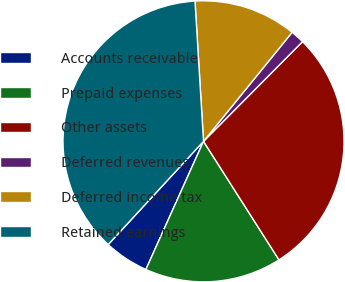<chart> <loc_0><loc_0><loc_500><loc_500><pie_chart><fcel>Accounts receivable<fcel>Prepaid expenses<fcel>Other assets<fcel>Deferred revenues<fcel>Deferred income tax<fcel>Retained earnings<nl><fcel>5.14%<fcel>15.75%<fcel>28.53%<fcel>1.58%<fcel>11.83%<fcel>37.17%<nl></chart> 